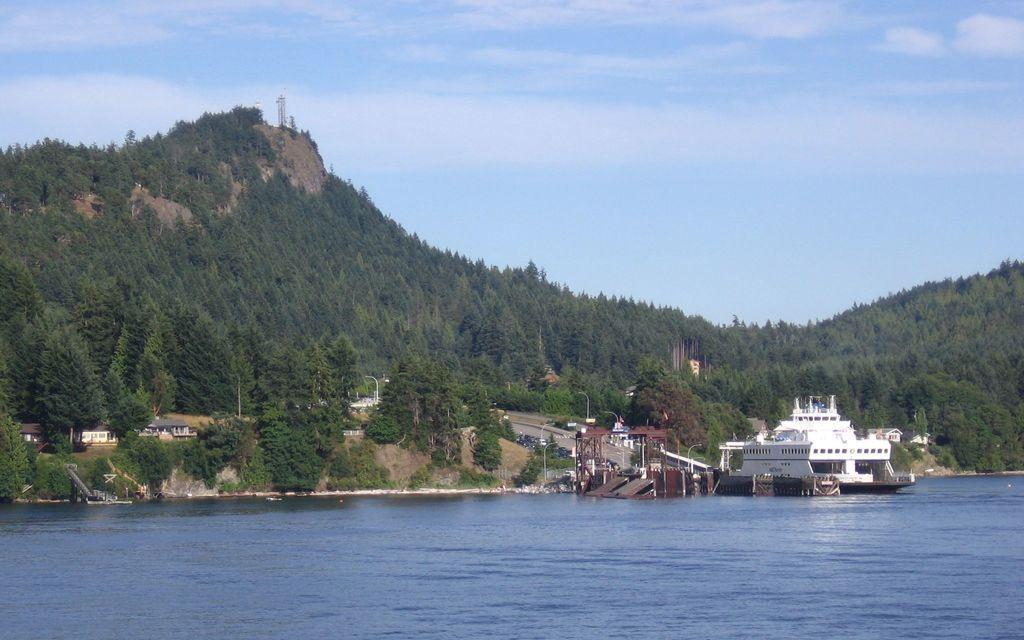Could you give a brief overview of what you see in this image? In this image I can see at the bottom there is water, on the right side it looks like a ship in white color. On the left side there are trees and houses, this is the hill, at the top it is the cloudy sky. 